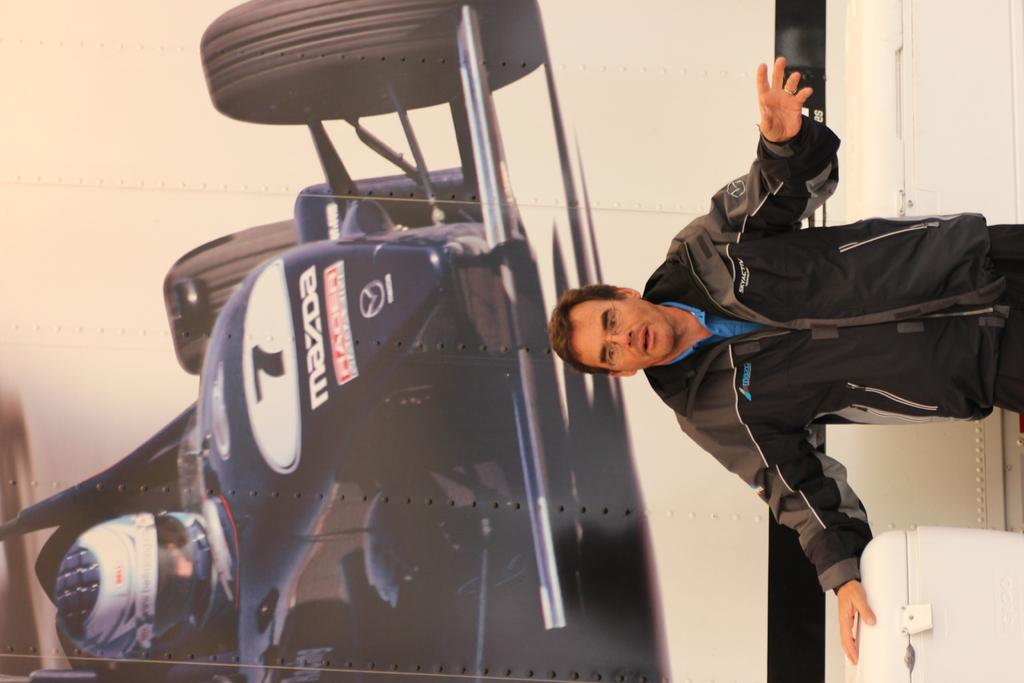<image>
Present a compact description of the photo's key features. a man stands infront of a picture of a car from mazda 